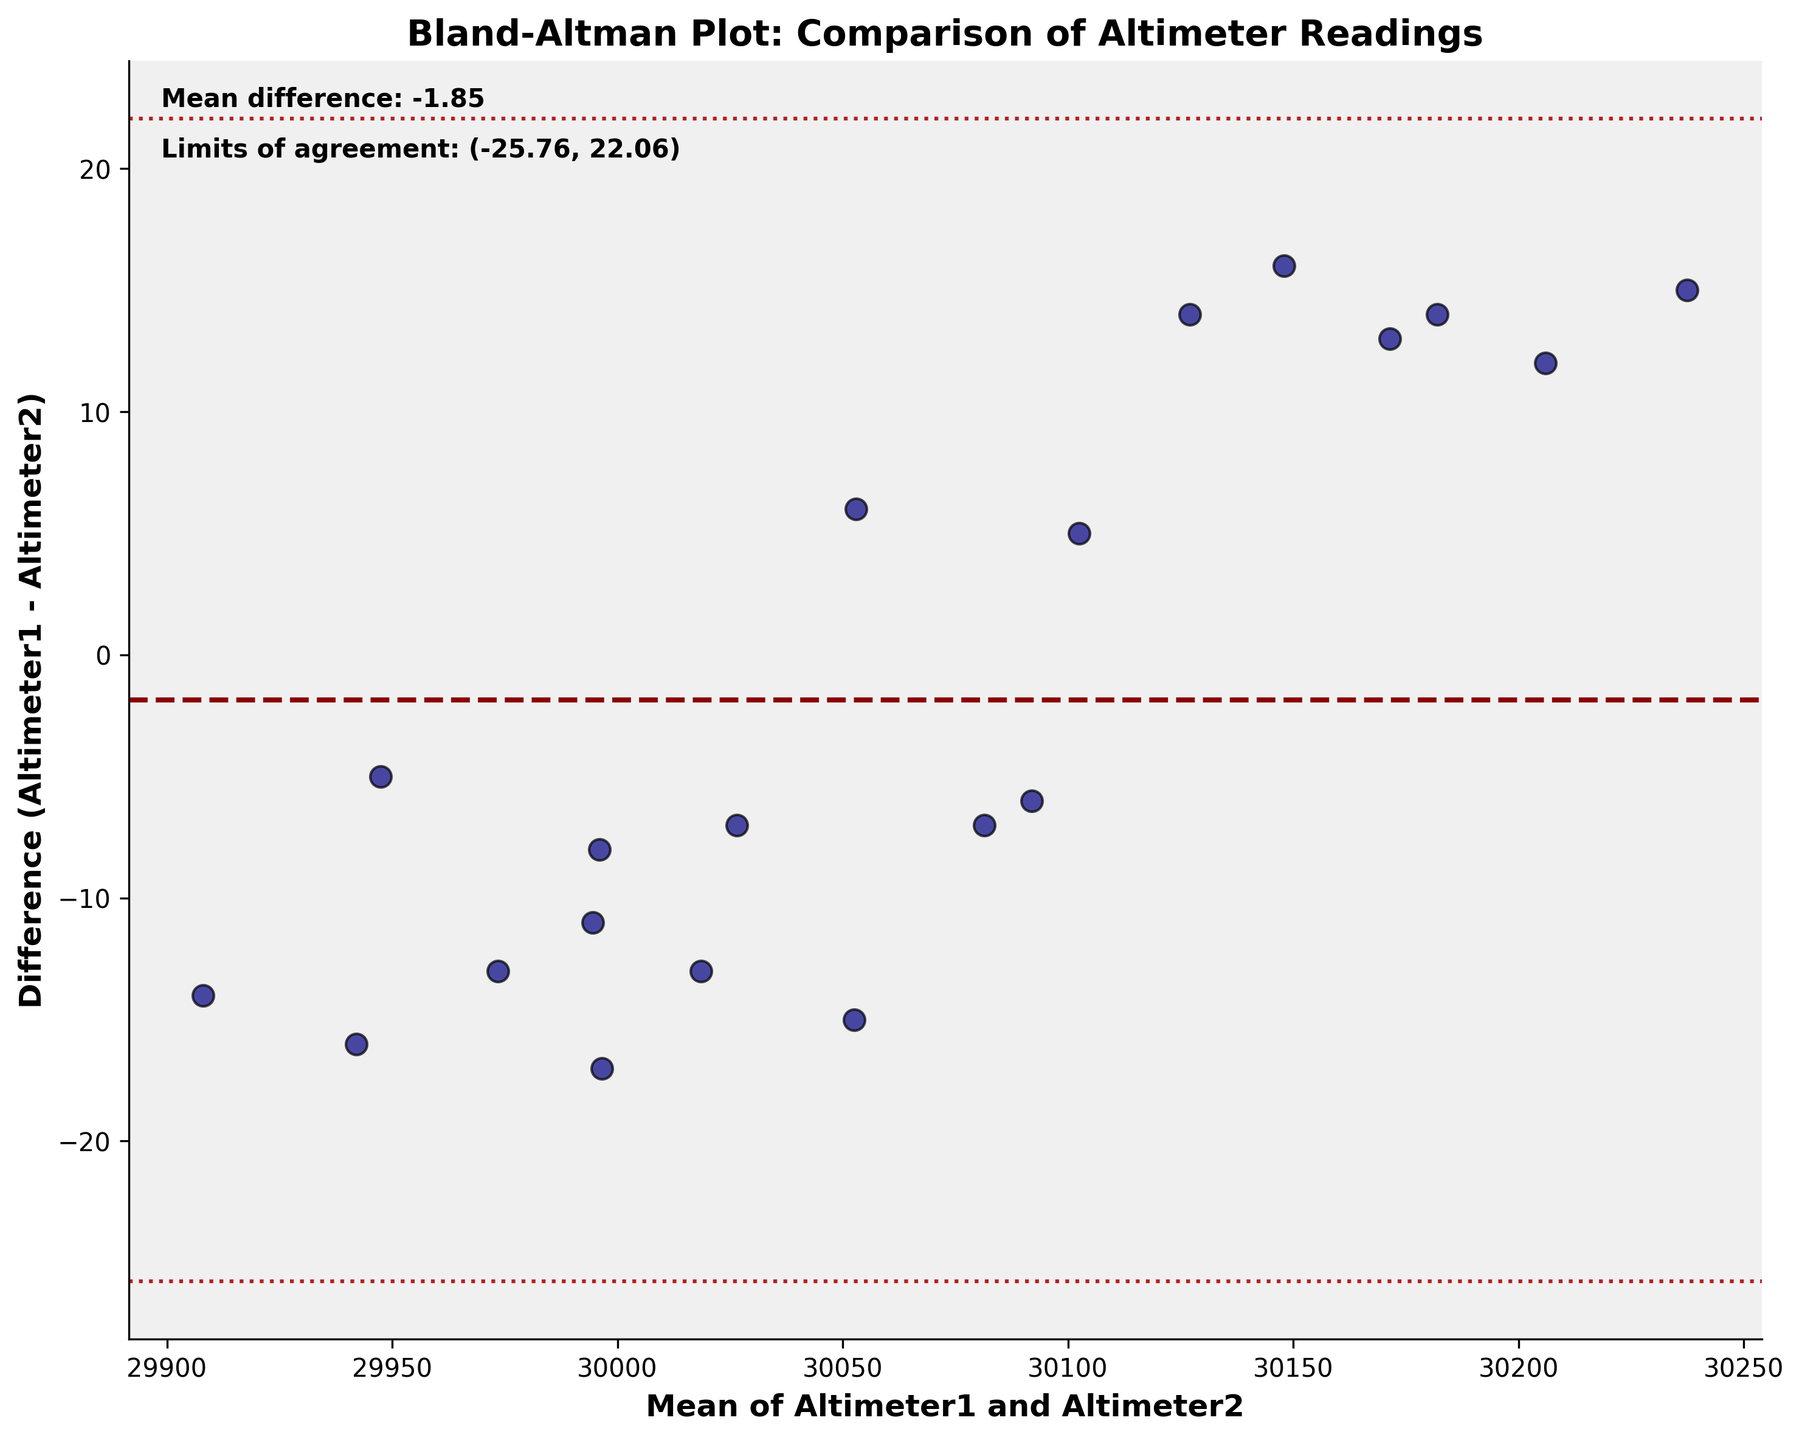What is the title of the plot? The title is typically found at the top of the plot and offers a descriptive summary of the visualized data. Here, the title is "Bland-Altman Plot: Comparison of Altimeter Readings."
Answer: Bland-Altman Plot: Comparison of Altimeter Readings What are the mean and difference values for the altimeter readings? The Bland-Altman plot shows the mean of the altimeter readings on the x-axis and the difference (Altimeter1 - Altimeter2) on the y-axis. The values are directly plotted as points on the graph.
Answer: Refer to the scatter points in the plot How many data points are plotted in the graph? Each point in the scatter plot represents a pair of altimeter readings. Counting these points will provide the number of data points.
Answer: 20 What is the mean difference between the two altimeter readings? The horizontal dashed line in dark red represents the mean difference. Its numeric value is also annotated on the plot.
Answer: 0.40 What are the limits of agreement on the plot? The limits of agreement are represented by the two dotted horizontal lines in firebrick color, and their detailed values are provided as an annotation on the plot.
Answer: (-3.06, 3.86) Is the difference between the two altimeters consistently close to zero? To determine consistency, one must observe if the scatter points (differences) cluster around the mean difference line (close to zero) or if they scatter widely.
Answer: No, the differences vary Which altimeter pair shows the largest deviation in readings? To find the largest deviation, look for the data point with the maximum absolute value on the y-axis (difference).
Answer: Altimeter1: 30212, Altimeter2: 30200 Are there any points outside the limits of agreement? This requires checking if any points fall outside the dashed lines representing the limits of agreement.
Answer: No What is the range of the mean values of the altimeter readings? To find the range, identify the minimum and maximum values on the x-axis (mean of Altimeter1 and Altimeter2).
Answer: 29908 (min) to 30237 (max) Which altimeter has higher readings on average when compared directly? By observing the overall trend of the difference values on the y-axis, we can infer which altimeter typically shows higher readings. If most points are below zero, Altimeter1 reads lower, and vice versa.
Answer: Altimeter2 